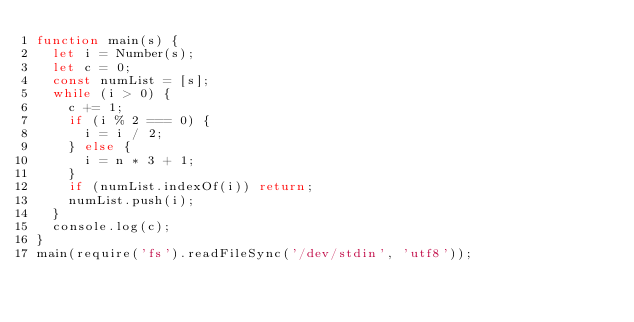<code> <loc_0><loc_0><loc_500><loc_500><_JavaScript_>function main(s) {
  let i = Number(s);
  let c = 0;
  const numList = [s];
  while (i > 0) {
    c += 1;
    if (i % 2 === 0) {
      i = i / 2;
    } else {
      i = n * 3 + 1;
    }
    if (numList.indexOf(i)) return;
    numList.push(i);
  }
  console.log(c);
}
main(require('fs').readFileSync('/dev/stdin', 'utf8'));
</code> 